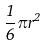<formula> <loc_0><loc_0><loc_500><loc_500>\frac { 1 } { 6 } \pi r ^ { 2 }</formula> 